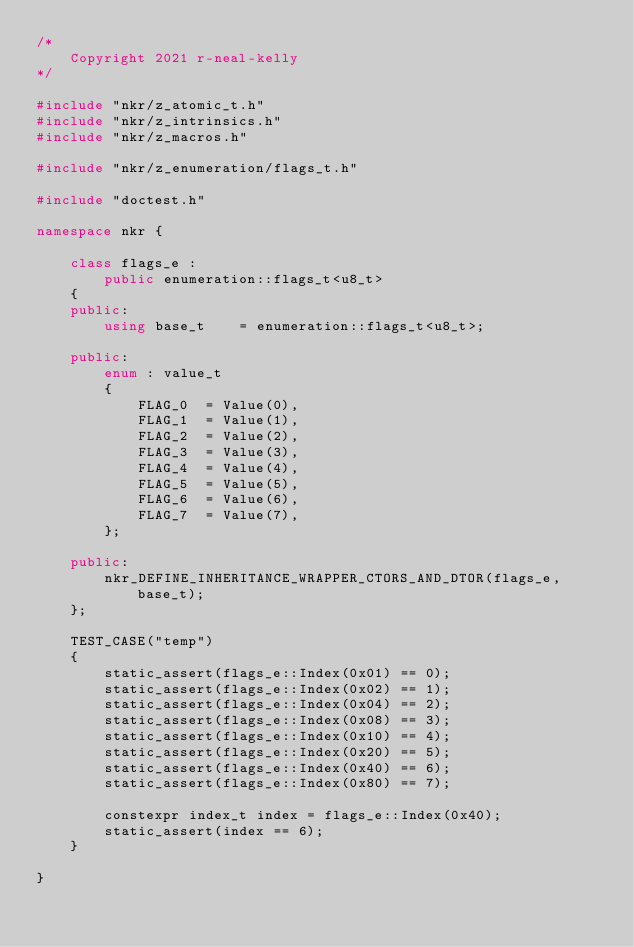Convert code to text. <code><loc_0><loc_0><loc_500><loc_500><_C++_>/*
    Copyright 2021 r-neal-kelly
*/

#include "nkr/z_atomic_t.h"
#include "nkr/z_intrinsics.h"
#include "nkr/z_macros.h"

#include "nkr/z_enumeration/flags_t.h"

#include "doctest.h"

namespace nkr {

    class flags_e :
        public enumeration::flags_t<u8_t>
    {
    public:
        using base_t    = enumeration::flags_t<u8_t>;

    public:
        enum : value_t
        {
            FLAG_0  = Value(0),
            FLAG_1  = Value(1),
            FLAG_2  = Value(2),
            FLAG_3  = Value(3),
            FLAG_4  = Value(4),
            FLAG_5  = Value(5),
            FLAG_6  = Value(6),
            FLAG_7  = Value(7),
        };

    public:
        nkr_DEFINE_INHERITANCE_WRAPPER_CTORS_AND_DTOR(flags_e, base_t);
    };

    TEST_CASE("temp")
    {
        static_assert(flags_e::Index(0x01) == 0);
        static_assert(flags_e::Index(0x02) == 1);
        static_assert(flags_e::Index(0x04) == 2);
        static_assert(flags_e::Index(0x08) == 3);
        static_assert(flags_e::Index(0x10) == 4);
        static_assert(flags_e::Index(0x20) == 5);
        static_assert(flags_e::Index(0x40) == 6);
        static_assert(flags_e::Index(0x80) == 7);

        constexpr index_t index = flags_e::Index(0x40);
        static_assert(index == 6);
    }

}
</code> 